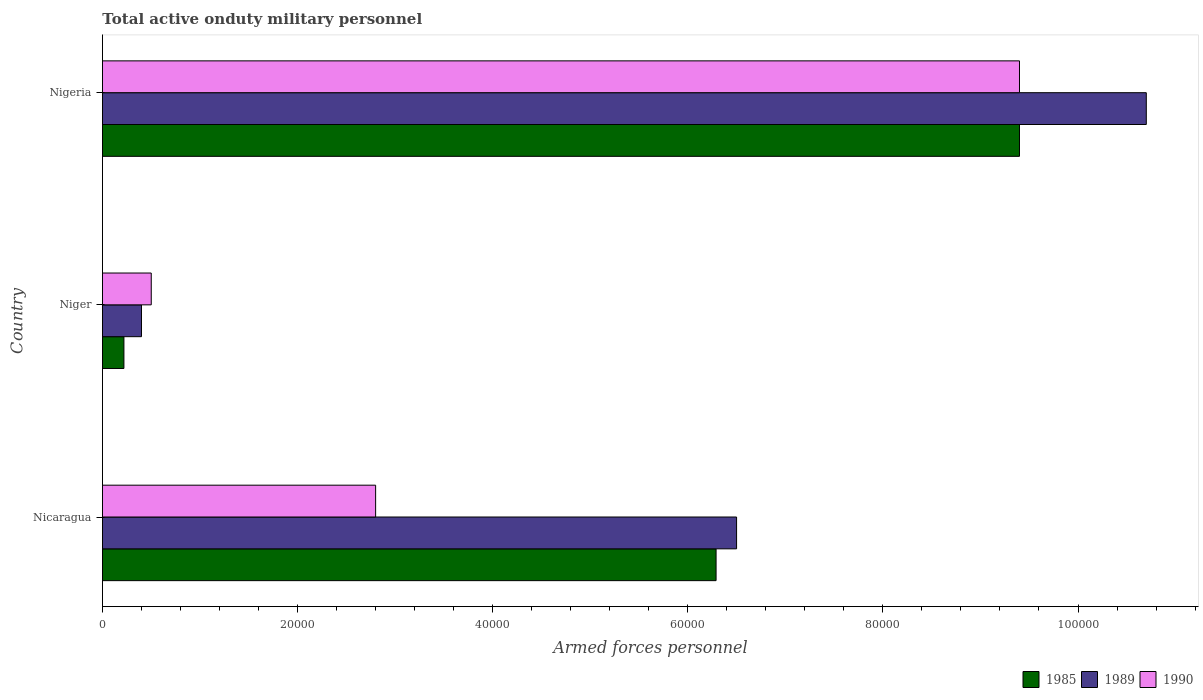How many different coloured bars are there?
Give a very brief answer. 3. How many groups of bars are there?
Offer a very short reply. 3. What is the label of the 1st group of bars from the top?
Make the answer very short. Nigeria. In how many cases, is the number of bars for a given country not equal to the number of legend labels?
Keep it short and to the point. 0. What is the number of armed forces personnel in 1990 in Nicaragua?
Offer a terse response. 2.80e+04. Across all countries, what is the maximum number of armed forces personnel in 1985?
Provide a succinct answer. 9.40e+04. In which country was the number of armed forces personnel in 1989 maximum?
Your response must be concise. Nigeria. In which country was the number of armed forces personnel in 1989 minimum?
Ensure brevity in your answer.  Niger. What is the total number of armed forces personnel in 1989 in the graph?
Offer a very short reply. 1.76e+05. What is the difference between the number of armed forces personnel in 1989 in Nicaragua and that in Niger?
Make the answer very short. 6.10e+04. What is the difference between the number of armed forces personnel in 1990 in Niger and the number of armed forces personnel in 1985 in Nigeria?
Your answer should be compact. -8.90e+04. What is the average number of armed forces personnel in 1989 per country?
Your answer should be compact. 5.87e+04. What is the difference between the number of armed forces personnel in 1990 and number of armed forces personnel in 1985 in Nicaragua?
Your response must be concise. -3.49e+04. What is the ratio of the number of armed forces personnel in 1985 in Nicaragua to that in Niger?
Provide a short and direct response. 28.59. Is the number of armed forces personnel in 1985 in Nicaragua less than that in Niger?
Provide a succinct answer. No. What is the difference between the highest and the second highest number of armed forces personnel in 1985?
Your answer should be compact. 3.11e+04. What is the difference between the highest and the lowest number of armed forces personnel in 1985?
Your response must be concise. 9.18e+04. In how many countries, is the number of armed forces personnel in 1985 greater than the average number of armed forces personnel in 1985 taken over all countries?
Offer a very short reply. 2. Is the sum of the number of armed forces personnel in 1989 in Nicaragua and Nigeria greater than the maximum number of armed forces personnel in 1990 across all countries?
Your answer should be compact. Yes. How many bars are there?
Make the answer very short. 9. How many countries are there in the graph?
Give a very brief answer. 3. Does the graph contain any zero values?
Provide a succinct answer. No. Where does the legend appear in the graph?
Offer a very short reply. Bottom right. How many legend labels are there?
Ensure brevity in your answer.  3. How are the legend labels stacked?
Ensure brevity in your answer.  Horizontal. What is the title of the graph?
Make the answer very short. Total active onduty military personnel. Does "2004" appear as one of the legend labels in the graph?
Make the answer very short. No. What is the label or title of the X-axis?
Provide a succinct answer. Armed forces personnel. What is the Armed forces personnel in 1985 in Nicaragua?
Give a very brief answer. 6.29e+04. What is the Armed forces personnel of 1989 in Nicaragua?
Your response must be concise. 6.50e+04. What is the Armed forces personnel in 1990 in Nicaragua?
Give a very brief answer. 2.80e+04. What is the Armed forces personnel of 1985 in Niger?
Offer a very short reply. 2200. What is the Armed forces personnel in 1989 in Niger?
Your answer should be very brief. 4000. What is the Armed forces personnel in 1985 in Nigeria?
Ensure brevity in your answer.  9.40e+04. What is the Armed forces personnel in 1989 in Nigeria?
Ensure brevity in your answer.  1.07e+05. What is the Armed forces personnel of 1990 in Nigeria?
Your answer should be compact. 9.40e+04. Across all countries, what is the maximum Armed forces personnel in 1985?
Provide a succinct answer. 9.40e+04. Across all countries, what is the maximum Armed forces personnel in 1989?
Provide a short and direct response. 1.07e+05. Across all countries, what is the maximum Armed forces personnel in 1990?
Keep it short and to the point. 9.40e+04. Across all countries, what is the minimum Armed forces personnel in 1985?
Your answer should be compact. 2200. Across all countries, what is the minimum Armed forces personnel in 1989?
Offer a very short reply. 4000. What is the total Armed forces personnel in 1985 in the graph?
Keep it short and to the point. 1.59e+05. What is the total Armed forces personnel in 1989 in the graph?
Keep it short and to the point. 1.76e+05. What is the total Armed forces personnel of 1990 in the graph?
Your response must be concise. 1.27e+05. What is the difference between the Armed forces personnel in 1985 in Nicaragua and that in Niger?
Provide a short and direct response. 6.07e+04. What is the difference between the Armed forces personnel in 1989 in Nicaragua and that in Niger?
Give a very brief answer. 6.10e+04. What is the difference between the Armed forces personnel of 1990 in Nicaragua and that in Niger?
Make the answer very short. 2.30e+04. What is the difference between the Armed forces personnel in 1985 in Nicaragua and that in Nigeria?
Ensure brevity in your answer.  -3.11e+04. What is the difference between the Armed forces personnel in 1989 in Nicaragua and that in Nigeria?
Provide a succinct answer. -4.20e+04. What is the difference between the Armed forces personnel of 1990 in Nicaragua and that in Nigeria?
Give a very brief answer. -6.60e+04. What is the difference between the Armed forces personnel of 1985 in Niger and that in Nigeria?
Make the answer very short. -9.18e+04. What is the difference between the Armed forces personnel in 1989 in Niger and that in Nigeria?
Offer a terse response. -1.03e+05. What is the difference between the Armed forces personnel of 1990 in Niger and that in Nigeria?
Offer a terse response. -8.90e+04. What is the difference between the Armed forces personnel in 1985 in Nicaragua and the Armed forces personnel in 1989 in Niger?
Give a very brief answer. 5.89e+04. What is the difference between the Armed forces personnel in 1985 in Nicaragua and the Armed forces personnel in 1990 in Niger?
Your answer should be compact. 5.79e+04. What is the difference between the Armed forces personnel in 1989 in Nicaragua and the Armed forces personnel in 1990 in Niger?
Make the answer very short. 6.00e+04. What is the difference between the Armed forces personnel in 1985 in Nicaragua and the Armed forces personnel in 1989 in Nigeria?
Your answer should be very brief. -4.41e+04. What is the difference between the Armed forces personnel of 1985 in Nicaragua and the Armed forces personnel of 1990 in Nigeria?
Give a very brief answer. -3.11e+04. What is the difference between the Armed forces personnel of 1989 in Nicaragua and the Armed forces personnel of 1990 in Nigeria?
Provide a succinct answer. -2.90e+04. What is the difference between the Armed forces personnel in 1985 in Niger and the Armed forces personnel in 1989 in Nigeria?
Offer a terse response. -1.05e+05. What is the difference between the Armed forces personnel in 1985 in Niger and the Armed forces personnel in 1990 in Nigeria?
Your answer should be compact. -9.18e+04. What is the average Armed forces personnel in 1985 per country?
Ensure brevity in your answer.  5.30e+04. What is the average Armed forces personnel of 1989 per country?
Offer a very short reply. 5.87e+04. What is the average Armed forces personnel in 1990 per country?
Your answer should be very brief. 4.23e+04. What is the difference between the Armed forces personnel in 1985 and Armed forces personnel in 1989 in Nicaragua?
Offer a terse response. -2100. What is the difference between the Armed forces personnel in 1985 and Armed forces personnel in 1990 in Nicaragua?
Make the answer very short. 3.49e+04. What is the difference between the Armed forces personnel of 1989 and Armed forces personnel of 1990 in Nicaragua?
Offer a very short reply. 3.70e+04. What is the difference between the Armed forces personnel of 1985 and Armed forces personnel of 1989 in Niger?
Your answer should be very brief. -1800. What is the difference between the Armed forces personnel of 1985 and Armed forces personnel of 1990 in Niger?
Your response must be concise. -2800. What is the difference between the Armed forces personnel in 1989 and Armed forces personnel in 1990 in Niger?
Provide a short and direct response. -1000. What is the difference between the Armed forces personnel of 1985 and Armed forces personnel of 1989 in Nigeria?
Make the answer very short. -1.30e+04. What is the difference between the Armed forces personnel of 1989 and Armed forces personnel of 1990 in Nigeria?
Give a very brief answer. 1.30e+04. What is the ratio of the Armed forces personnel of 1985 in Nicaragua to that in Niger?
Make the answer very short. 28.59. What is the ratio of the Armed forces personnel of 1989 in Nicaragua to that in Niger?
Offer a very short reply. 16.25. What is the ratio of the Armed forces personnel in 1985 in Nicaragua to that in Nigeria?
Offer a very short reply. 0.67. What is the ratio of the Armed forces personnel of 1989 in Nicaragua to that in Nigeria?
Your answer should be compact. 0.61. What is the ratio of the Armed forces personnel in 1990 in Nicaragua to that in Nigeria?
Provide a short and direct response. 0.3. What is the ratio of the Armed forces personnel in 1985 in Niger to that in Nigeria?
Offer a terse response. 0.02. What is the ratio of the Armed forces personnel of 1989 in Niger to that in Nigeria?
Ensure brevity in your answer.  0.04. What is the ratio of the Armed forces personnel in 1990 in Niger to that in Nigeria?
Give a very brief answer. 0.05. What is the difference between the highest and the second highest Armed forces personnel of 1985?
Keep it short and to the point. 3.11e+04. What is the difference between the highest and the second highest Armed forces personnel in 1989?
Your answer should be compact. 4.20e+04. What is the difference between the highest and the second highest Armed forces personnel of 1990?
Your answer should be very brief. 6.60e+04. What is the difference between the highest and the lowest Armed forces personnel of 1985?
Give a very brief answer. 9.18e+04. What is the difference between the highest and the lowest Armed forces personnel in 1989?
Provide a succinct answer. 1.03e+05. What is the difference between the highest and the lowest Armed forces personnel of 1990?
Provide a succinct answer. 8.90e+04. 